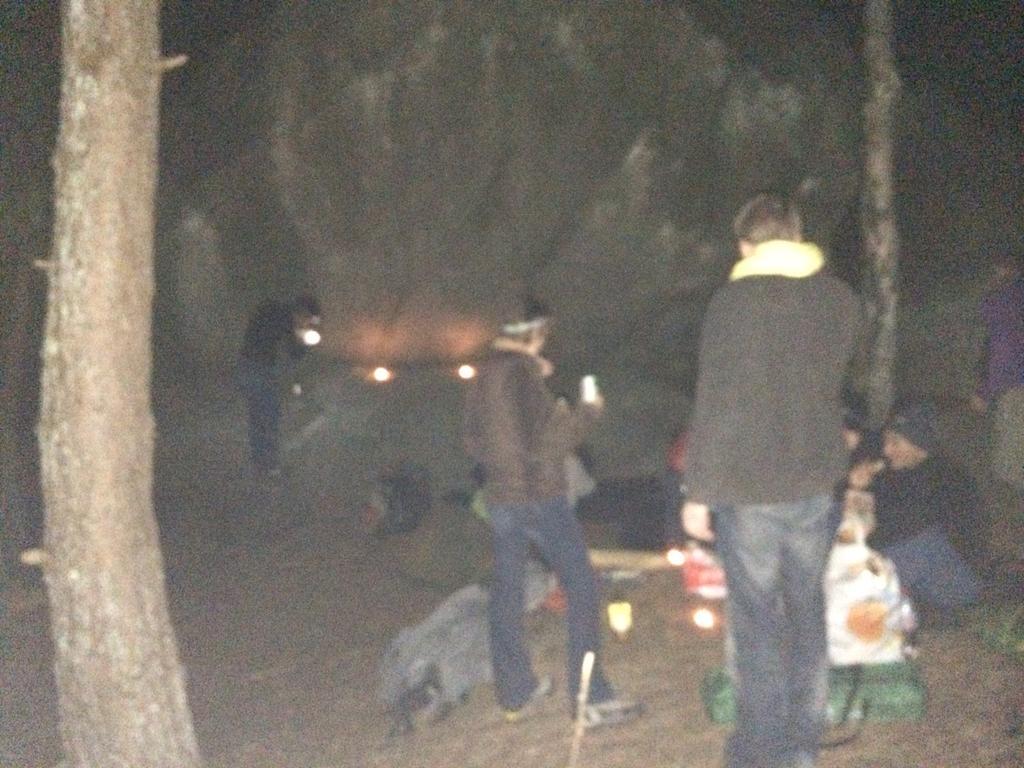Can you describe this image briefly? In this image few persons are standing on the land. Few objects are on the land. Background there are few trees. Left side there is a tree trunk. Right side a person is sitting on the land. 